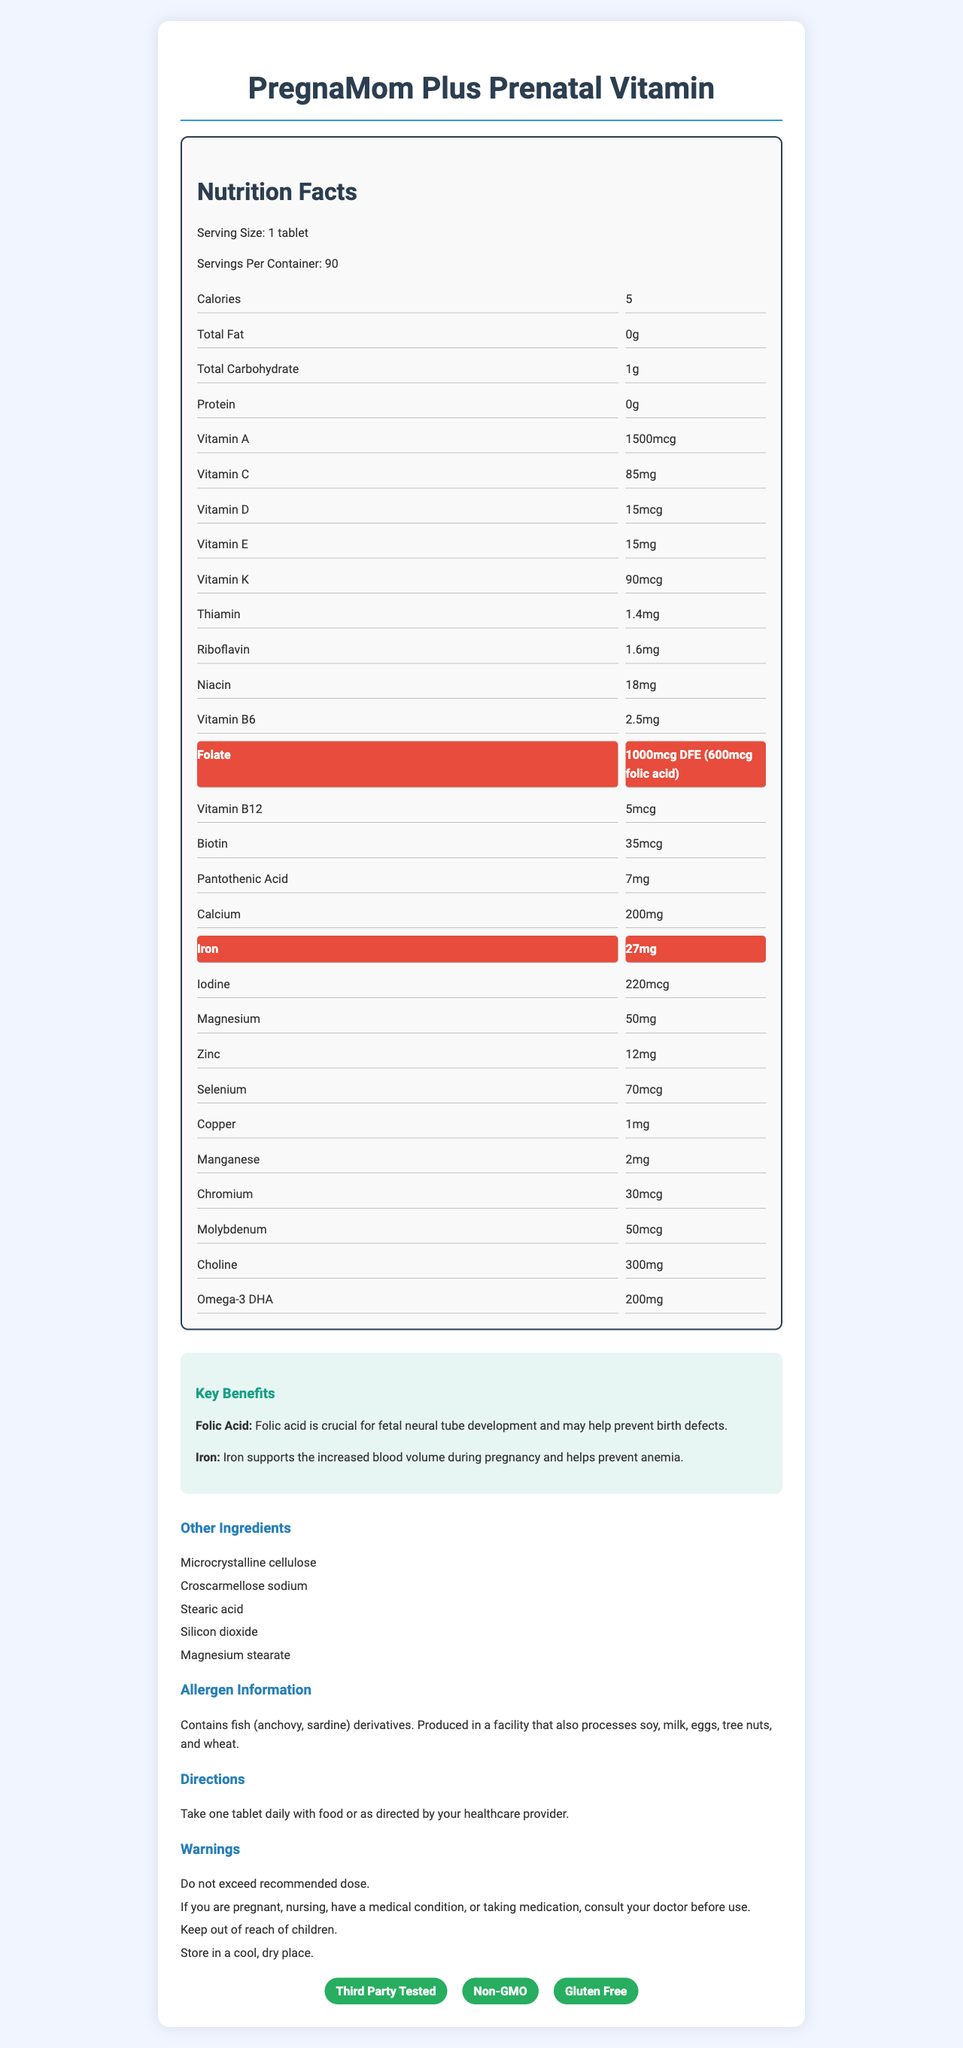What is the serving size mentioned for the Prenatal Vitamin? The document lists the serving size as "1 tablet" under the "Nutrition Facts" header.
Answer: 1 tablet How many servings are included in one container? The document indicates that there are 90 servings per container.
Answer: 90 What is the amount of folic acid in the supplement? The document highlights the folate content as "1000mcg DFE (600mcg folic acid)".
Answer: 600mcg How much iron does each serving contain? The iron content per serving is highlighted as 27mg in the document.
Answer: 27mg What does the document suggest about when to take the tablets? The directions state to "Take one tablet daily with food or as directed by your healthcare provider."
Answer: Daily with food or as directed by your healthcare provider Which of the following vitamins are listed in the supplement? A. Vitamin B12 B. Vitamin B7 C. Vitamin K D. Vitamin A The document lists Vitamin B12 (5mcg), Vitamin K (90mcg), and Vitamin A (1500mcg) but not Vitamin B7.
Answer: A, C, D What is the potential benefit of folic acid in prenatal vitamins according to the document? The benefits section states that folic acid is crucial for fetal neural tube development and may help prevent birth defects.
Answer: Helps prevent birth defects and supports fetal neural tube development Does this supplement contain any fish derivatives? The allergen information section explicitly states that it contains fish (anchovy, sardine) derivatives.
Answer: Yes Is this prenatal vitamin tested by a third party? The document includes a badge that states "Third Party Tested."
Answer: Yes Summarize the key benefits of PregnaMom Plus Prenatal Vitamin. The document highlights folic acid and iron for their specific benefits and provides detailed information on the essential nutrients and their roles.
Answer: The key benefits of PregnaMom Plus Prenatal Vitamin include support for fetal neural tube development and prevention of birth defects via folic acid, along with supporting increased blood volume during pregnancy and preventing anemia via iron. Can this supplement be taken on an empty stomach? The directions suggest taking it with food or as directed by a healthcare provider, implying it should not ideally be taken on an empty stomach.
Answer: Not recommended Are there any storage recommendations for this supplement? The warnings section of the document advises keeping it in a cool, dry place.
Answer: Store in a cool, dry place What is the format of the nutrition facts? A. Bullet points B. Grid C. Paragraph The nutrition facts are displayed in a grid format.
Answer: B. Grid What kind of safety warnings are included in the document? The warnings section provides specific safety instructions.
Answer: Do not exceed the recommended dose, consult a doctor if pregnant or nursing, keep out of reach of children Apart from standard vitamins and minerals, what other key ingredient is mentioned? The document specifies Omega-3 DHA as a key ingredient, apart from the standard vitamins and minerals.
Answer: Omega-3 DHA (200mg) List two components found in the "Other Ingredients" section. The "Other Ingredients" section lists multiple components including Microcrystalline cellulose and Stearic acid.
Answer: Microcrystalline cellulose, Stearic acid Is this supplement suitable for vegetarians? The document explicitly states that the supplement is not vegetarian under the badges section.
Answer: No Can the benefits of thiamin in the supplement be found in the document? While thiamin is listed in the nutritional content, the document does not specifically describe its benefits.
Answer: No, the benefits of thiamin are not described 